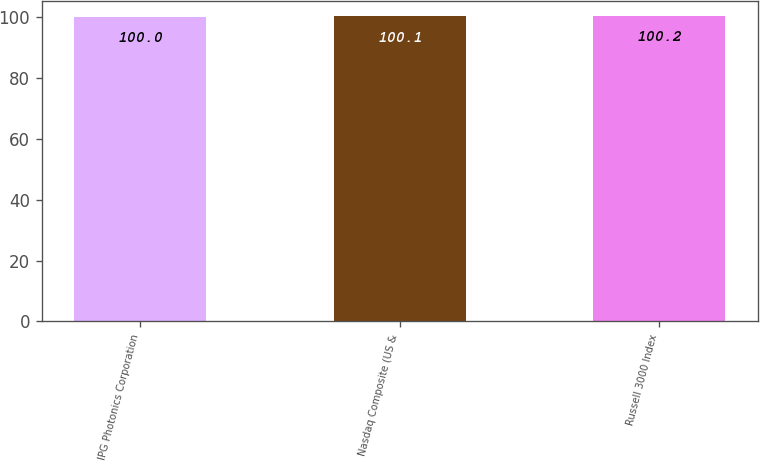Convert chart. <chart><loc_0><loc_0><loc_500><loc_500><bar_chart><fcel>IPG Photonics Corporation<fcel>Nasdaq Composite (US &<fcel>Russell 3000 Index<nl><fcel>100<fcel>100.1<fcel>100.2<nl></chart> 